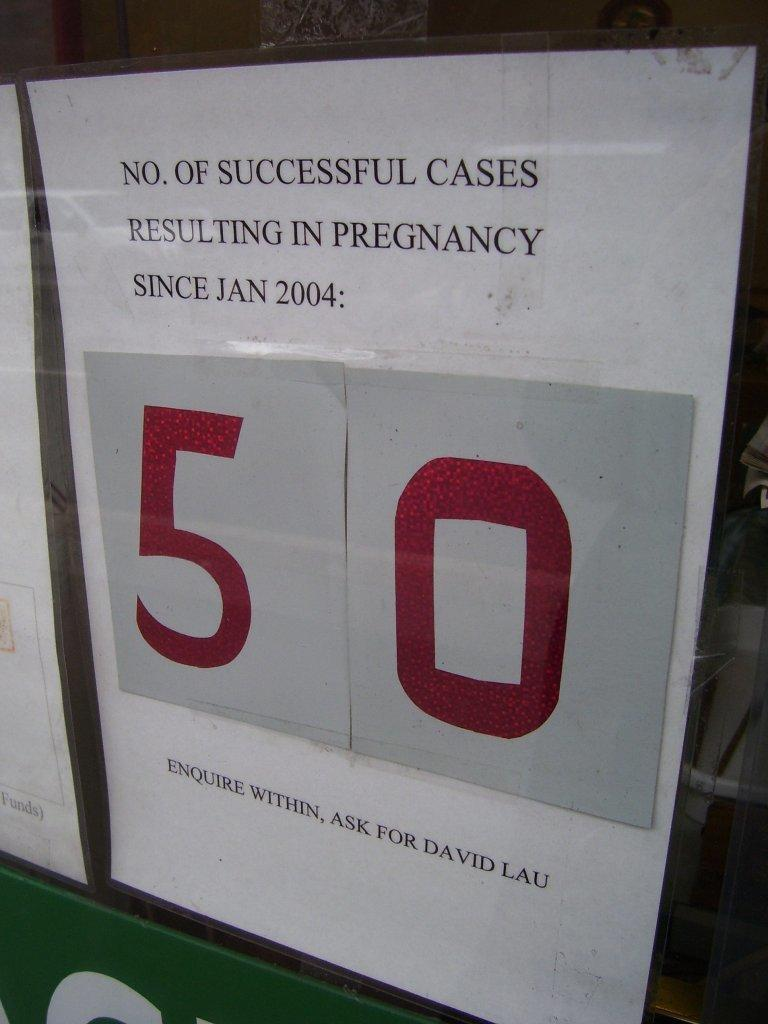<image>
Write a terse but informative summary of the picture. A sheet that says No. of successful cases resulting in pregnancy since Jan 2004 is 50 